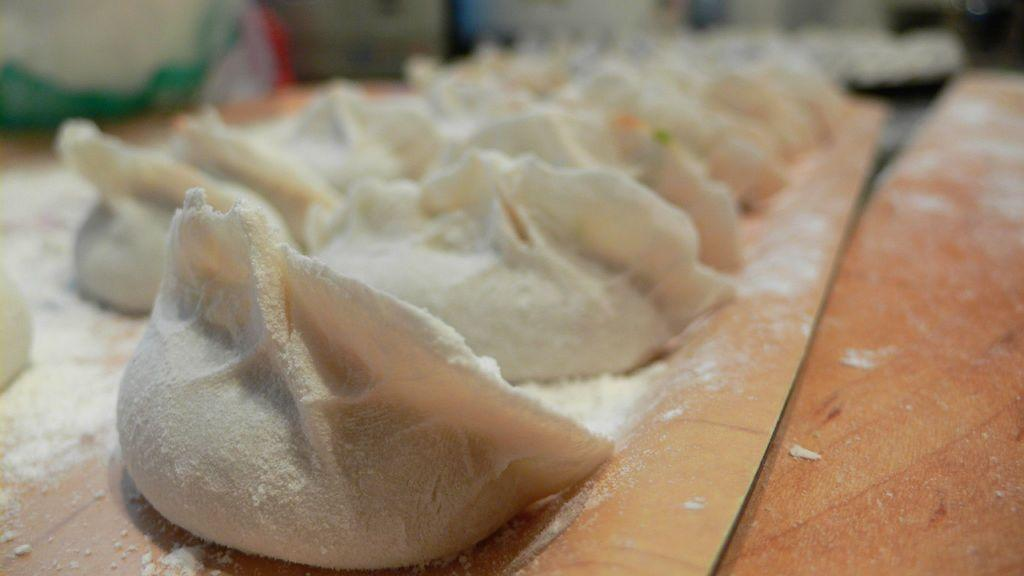What type of snacks are visible in the image? There are raw flour snacks in the image. What is the color of the surface on which the snacks are placed? The snacks are on a brown color surface. How does the sand interact with the raw flour snacks in the image? There is no sand present in the image, so it cannot interact with the raw flour snacks. 